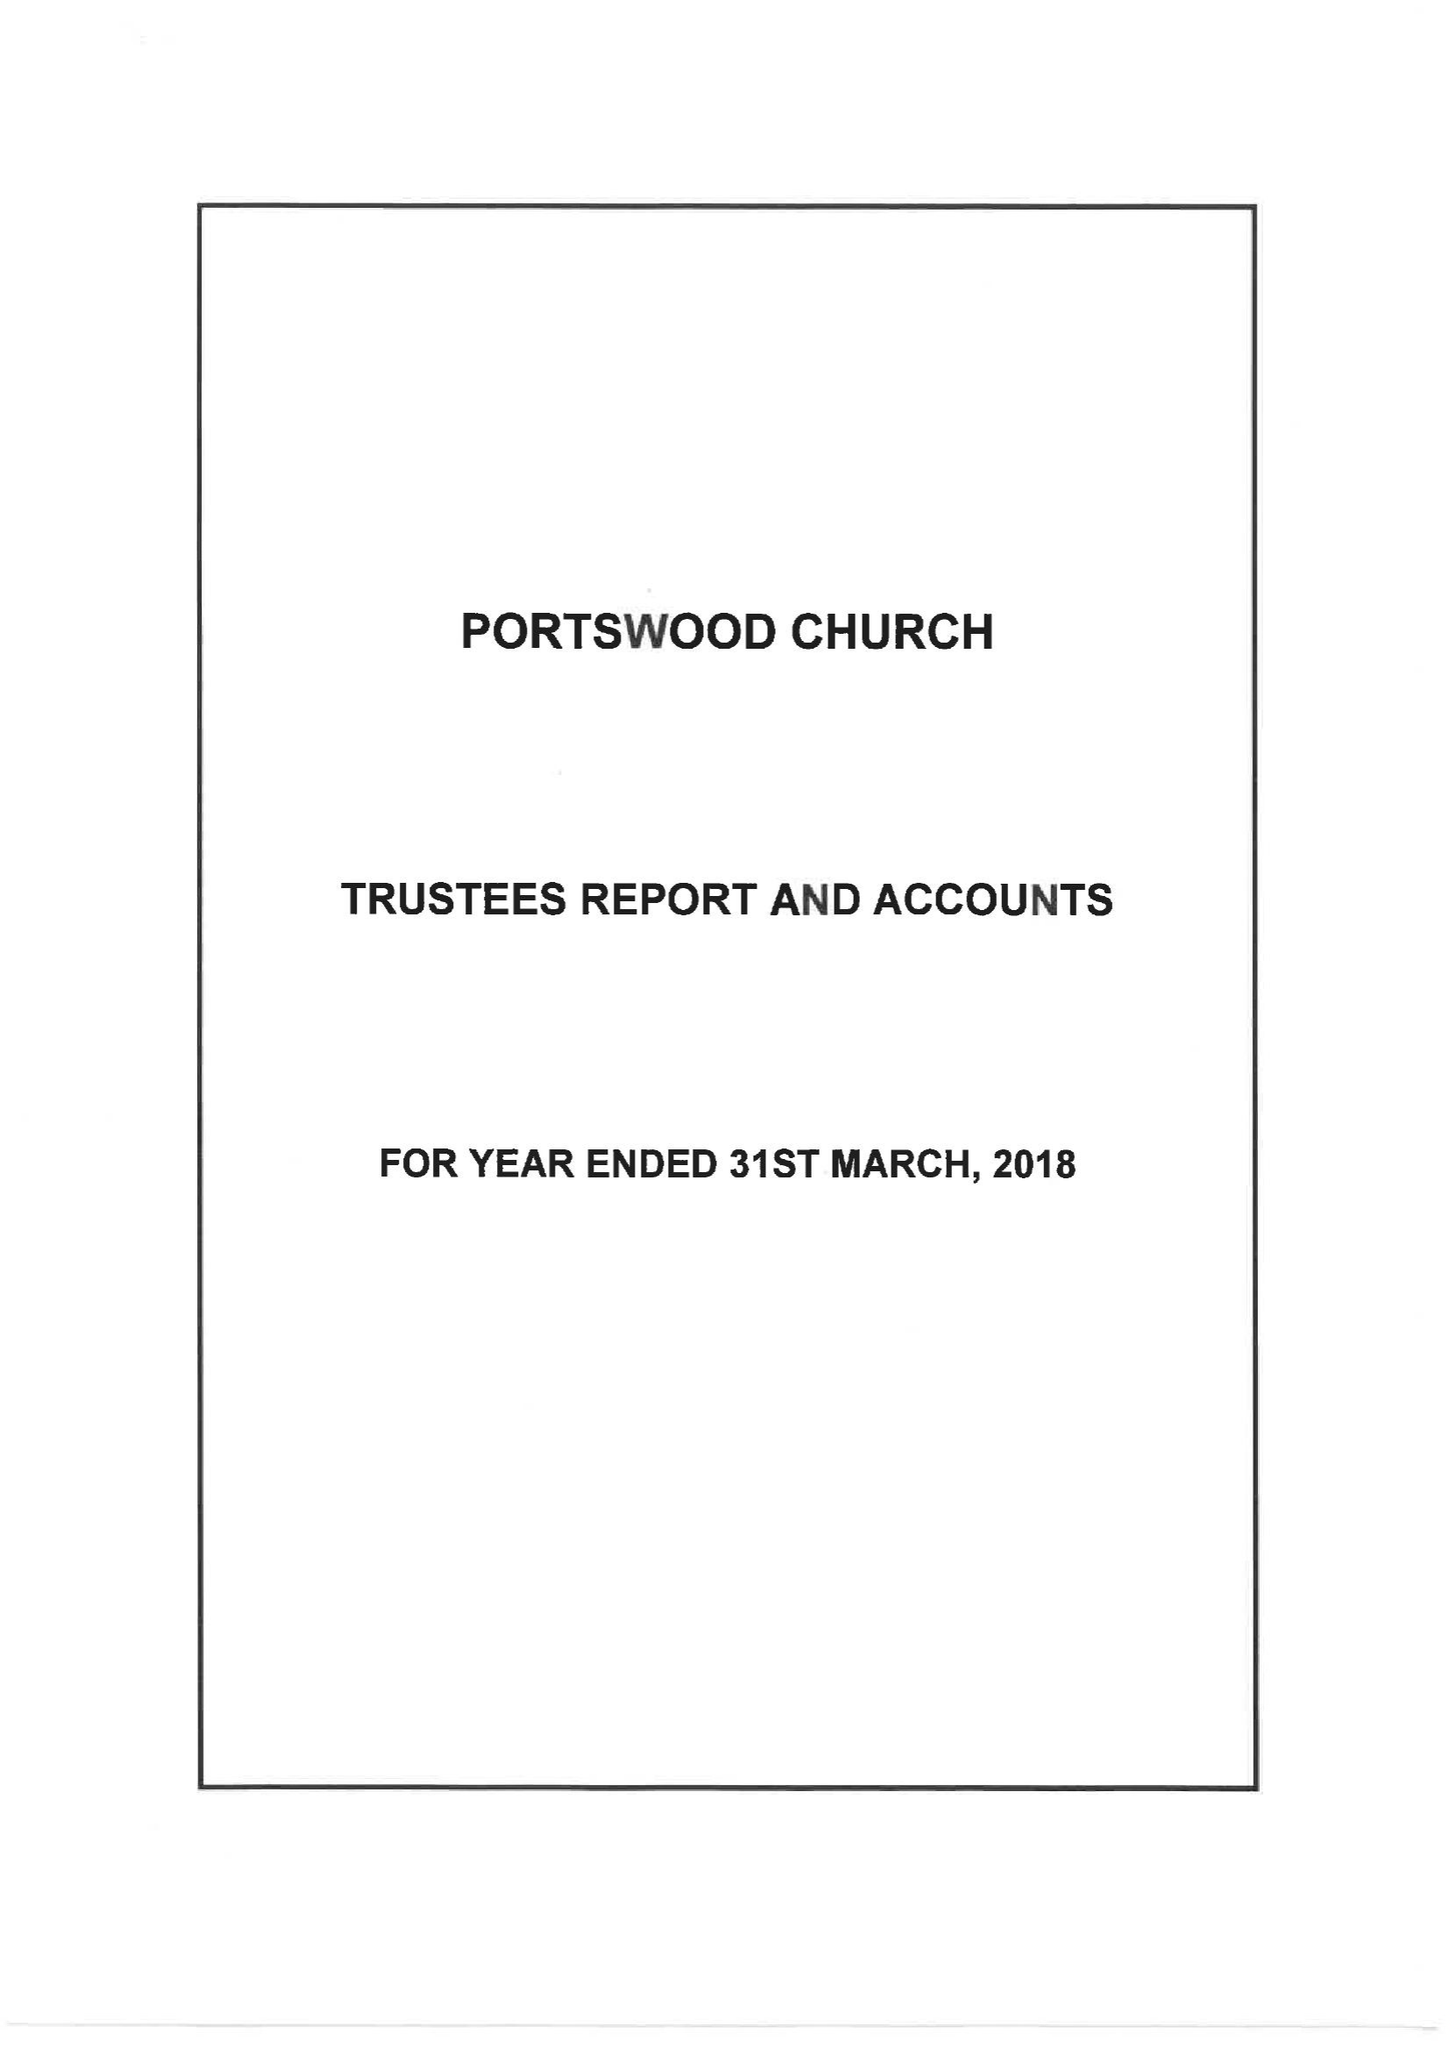What is the value for the address__post_town?
Answer the question using a single word or phrase. SOUTHAMPTON 